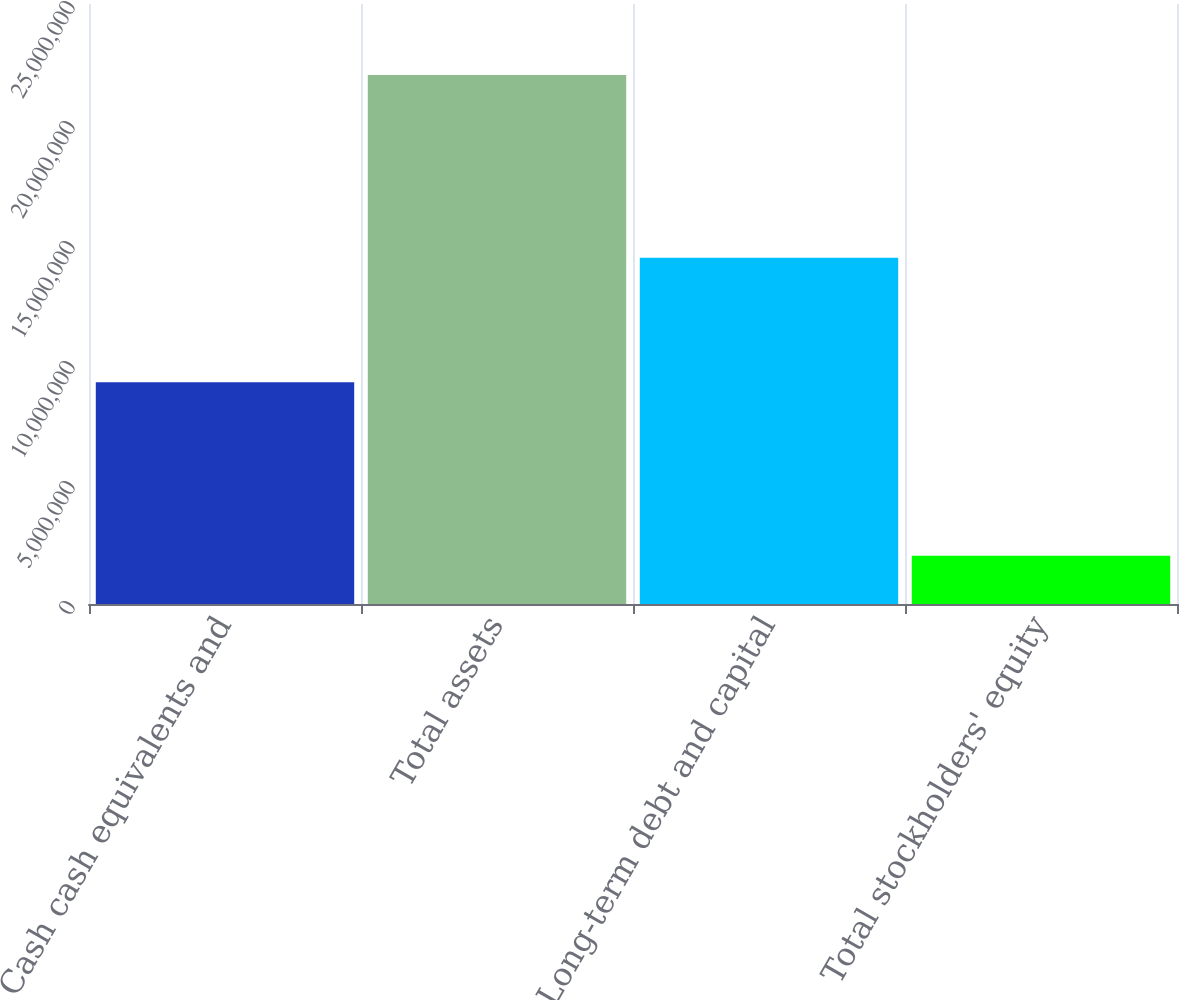Convert chart to OTSL. <chart><loc_0><loc_0><loc_500><loc_500><bar_chart><fcel>Cash cash equivalents and<fcel>Total assets<fcel>Long-term debt and capital<fcel>Total stockholders' equity<nl><fcel>9.23624e+06<fcel>2.20455e+07<fcel>1.44275e+07<fcel>2.01213e+06<nl></chart> 